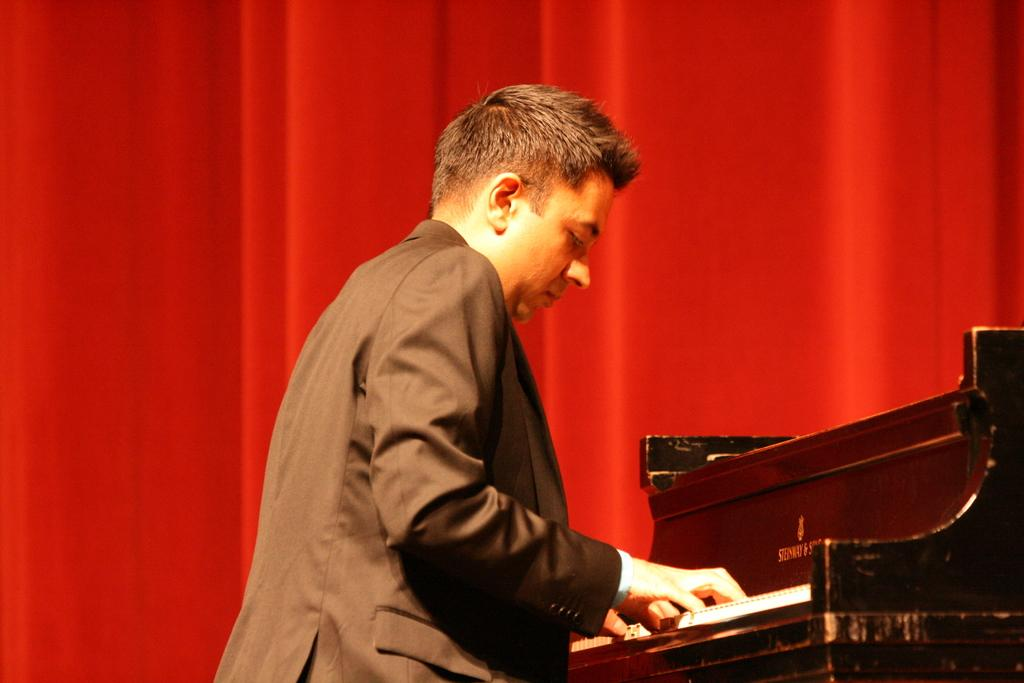Who is the main subject in the image? There is a man in the center of the image. What is the man doing in the image? The man is playing a piano. What is the man wearing in the image? The man is wearing a suit. What can be seen in the background of the image? There is a curtain in the background of the image. What type of stew is being cooked on the farm in the image? There is no farm or stew present in the image; it features a man playing a piano. How does the man ensure his comfort while playing the piano in the image? The image does not provide information about the man's comfort while playing the piano. 